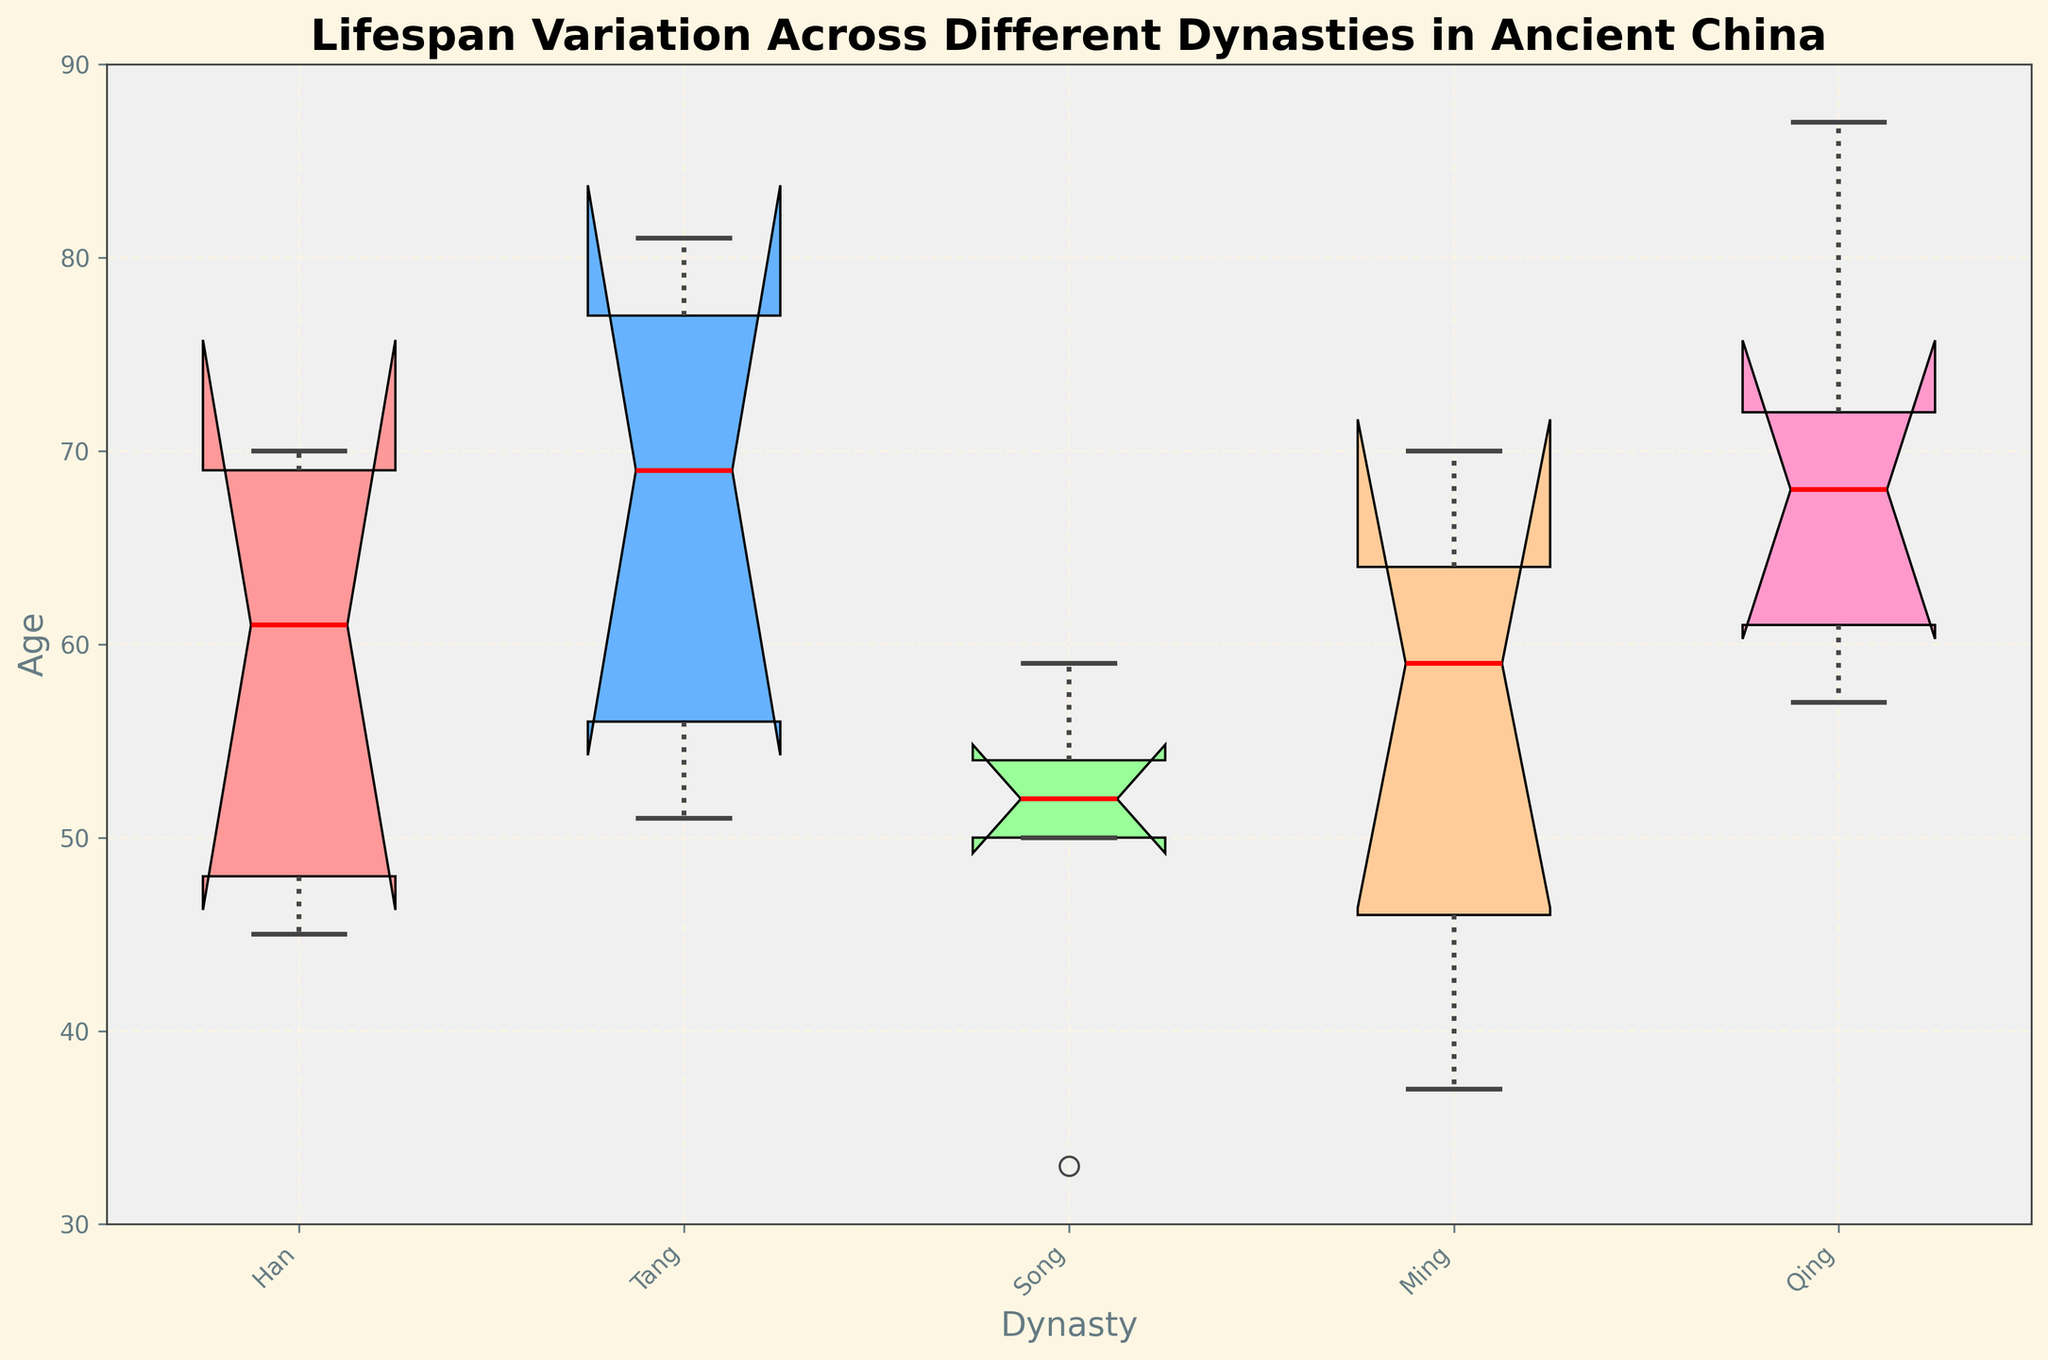What's the title of the figure? The title appears at the top of the figure and provides the overall context for what is being depicted. It reads "Lifespan Variation Across Different Dynasties in Ancient China".
Answer: Lifespan Variation Across Different Dynasties in Ancient China Which dynasty has the highest median lifespan? The line inside each box represents the median lifespan for each dynasty. By looking at these lines, the Qing dynasty shows the highest median, situated higher than the other dynasties.
Answer: Qing How many dynasties are represented in the figure? Each box represents a different dynasty. Counting the number of boxes gives the number of represented dynasties. The figure shows five boxes.
Answer: Five Which dynasty has the shortest range of lifespans? Range is indicated by the distance between the ends of the whiskers. The Song dynasty has the shortest distance between its whiskers compared to other dynasties.
Answer: Song What color represents the Han dynasty's box? Each box is filled with a specific color. The Han dynasty's box is filled with a light reddish color.
Answer: Light reddish How does the median lifespan of the Tang dynasty compare to the Song dynasty? The median is the line within each box. The Tang dynasty's median line is slightly higher than the Song dynasty's, indicating a longer median lifespan.
Answer: Tang's median is higher What's the interquartile range (IQR) for the Ming dynasty? The IQR is the distance between the bottom and top edges of the box, representing the 25th and 75th percentiles. For the Ming dynasty, this distance can be observed directly.
Answer: Approximately 46 to 64 Which dynasty shows the largest variation in lifespan? Variation is largest where the distance between the whiskers is greatest. The figure shows that the Qing dynasty has the widest range, indicating the highest variation in lifespan.
Answer: Qing Are there any outliers depicted in the figure? If so, for which dynasty? Outliers are shown as individual points outside the whiskers. By examining the plot, we can see that the Ming dynasty has one outlier above the whiskers.
Answer: Ming What can the notches tell us about the significance of median differences? The notches provide a visual indication of the confidence interval around the median. Overlapping notches between dynasties like the Han and Tang suggest their median lifespans may not be significantly different.
Answer: Overlapping notches indicate non-significant differences 